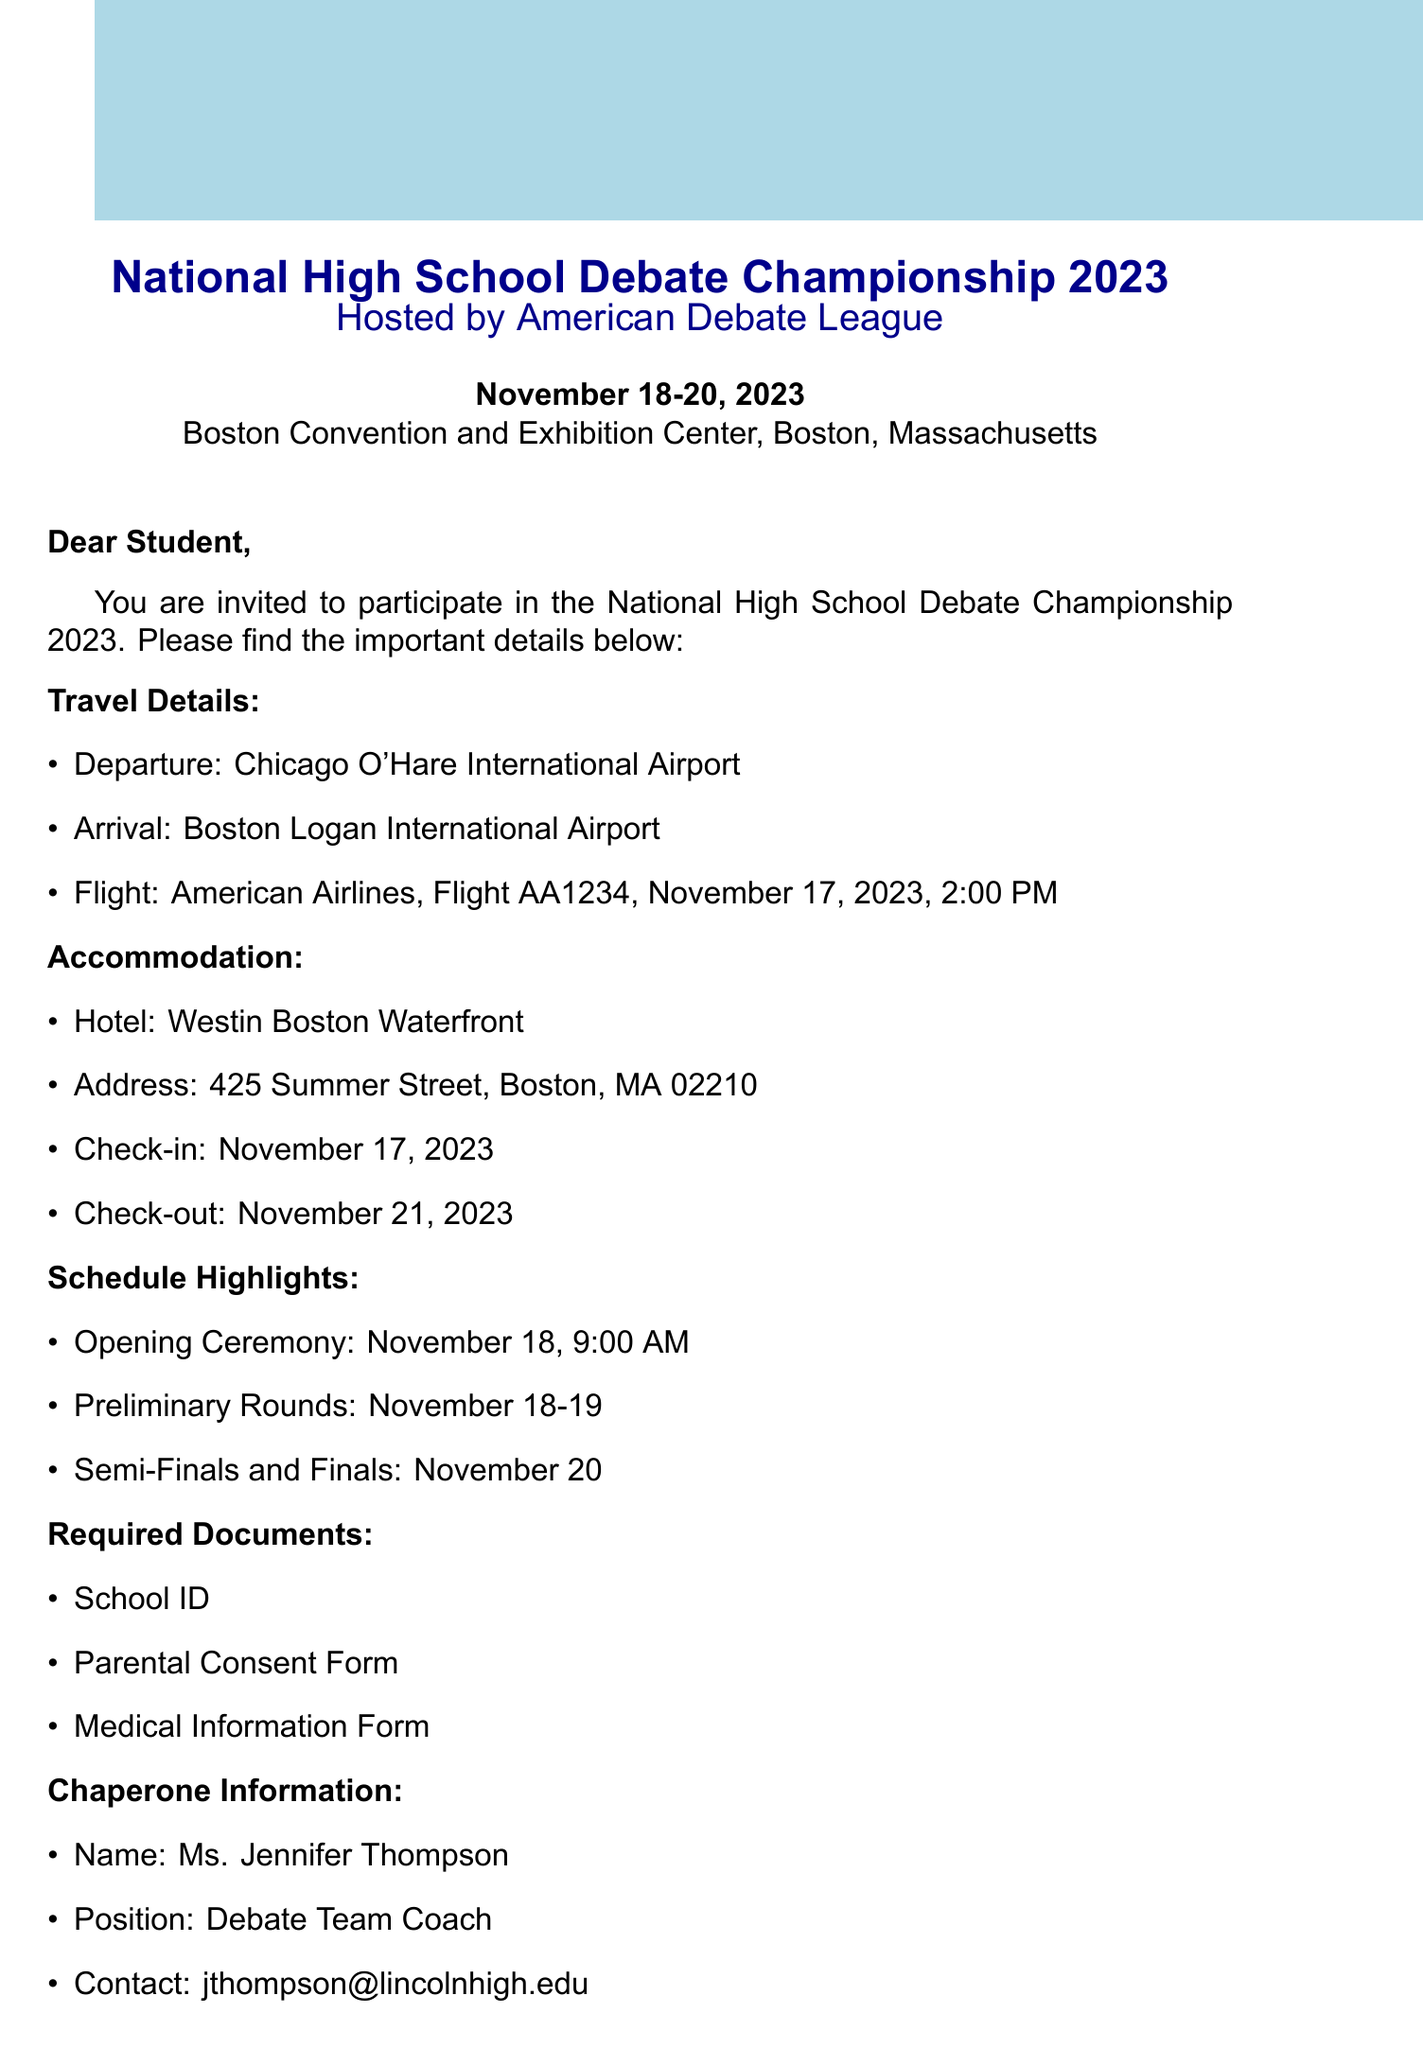what is the host organization? The host organization mentioned in the document is responsible for organizing the event, which is the American Debate League.
Answer: American Debate League what are the event dates? The event dates indicate when the championship will take place, which is listed in the document as November 18-20, 2023.
Answer: November 18-20, 2023 where is the championship located? The location of the championship provides information about where the event will be held, specifically noted in the document as the Boston Convention and Exhibition Center, Boston, Massachusetts.
Answer: Boston Convention and Exhibition Center, Boston, Massachusetts when is the check-in date for the hotel? The check-in date for the hotel indicates when participants should arrive at their accommodation, which is specified as November 17, 2023.
Answer: November 17, 2023 who is the chaperone? The chaperone is an individual responsible for overseeing students during the event, identified in the document as Ms. Jennifer Thompson, the Debate Team Coach.
Answer: Ms. Jennifer Thompson what is the flight number for the travel? The flight number is a key detail for flight arrangements, noted in the document as American Airlines, Flight AA1234.
Answer: Flight AA1234 what forms are required for participation? The document lists necessary forms for participants, which include a School ID, Parental Consent Form, and Medical Information Form.
Answer: School ID, Parental Consent Form, Medical Information Form when is the submission deadline for required forms? The submission deadline for required forms is essential for ensuring participation; it is specified as November 1, 2023.
Answer: November 1, 2023 